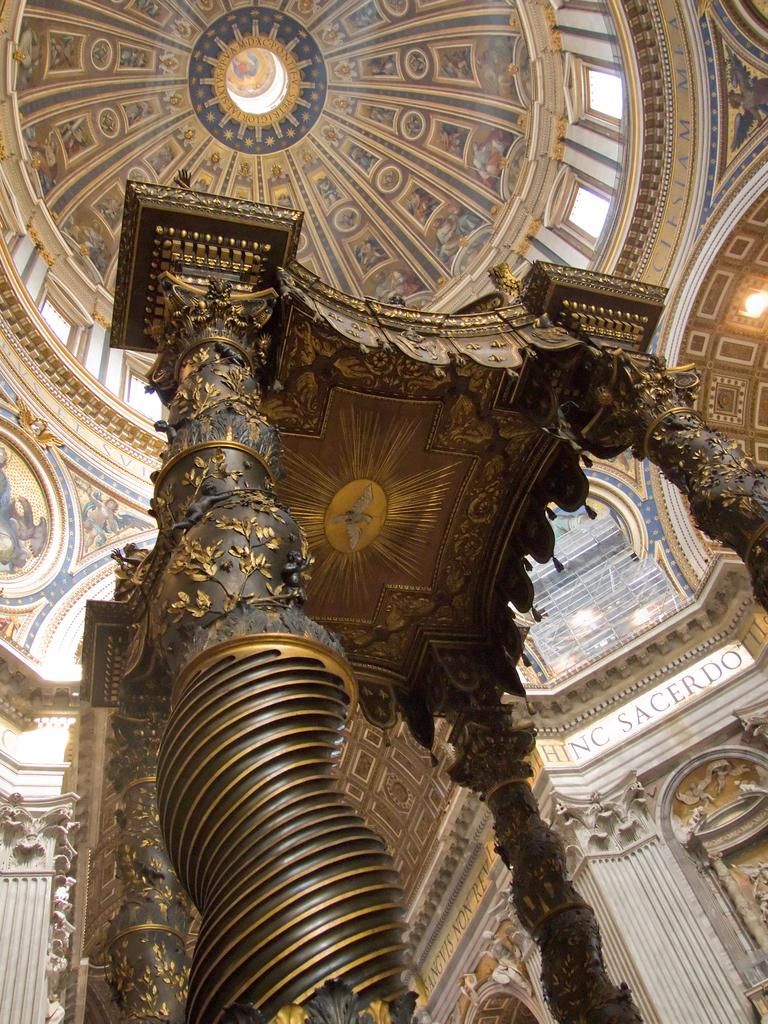What type of structure is visible in the image? There is a roof, several pillars, and a wall visible in the image. Can you describe the roof in the image? The roof is a part of the structure visible in the image. What other architectural elements can be seen in the image? There are several pillars visible in the image. Is there a beggar asking for alms in the image? There is no beggar present in the image. Can you tell me how many kittens are playing on the wall in the image? There are no kittens present in the image. 